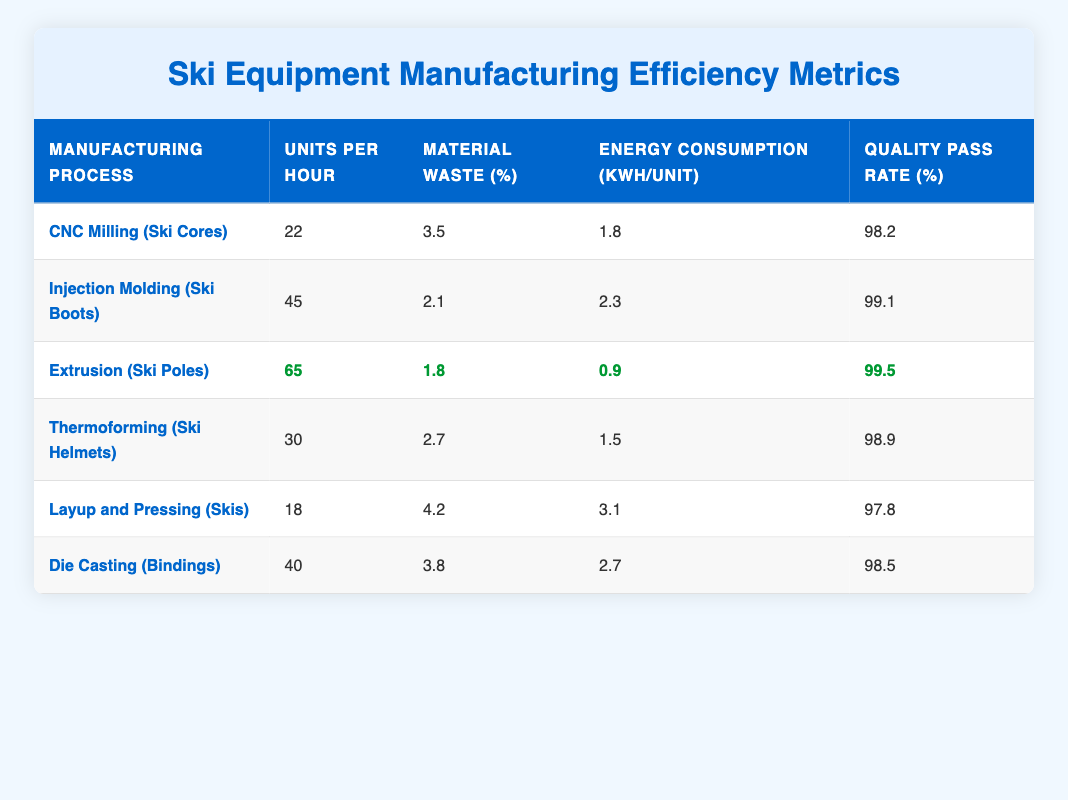What manufacturing process has the highest units produced per hour? By reviewing the "Units per Hour" column, I can see that the "Extrusion (Ski Poles)" process has the highest value at 65 units per hour, compared to others.
Answer: Extrusion (Ski Poles) Which manufacturing process has the lowest material waste percentage? Looking at the "Material Waste (%)" column, I can find that the "Extrusion (Ski Poles)" process has the lowest waste percentage at 1.8%.
Answer: Extrusion (Ski Poles) Is the quality pass rate for Injection Molding (Ski Boots) greater than 98%? Checking the "Quality Pass Rate (%)" for Injection Molding (Ski Boots), I see that it is 99.1%, which is indeed greater than 98%.
Answer: Yes What is the average energy consumption for all manufacturing processes listed? To find the average energy consumption, I sum all the values: (1.8 + 2.3 + 0.9 + 1.5 + 3.1 + 2.7) = 12.3 kWh. Then I divide by the number of processes, which is 6: 12.3 / 6 = 2.05 kWh per unit.
Answer: 2.05 kWh Which manufacturing process has both a quality pass rate greater than 98% and the lowest energy consumption? I examine the "Quality Pass Rate (%)" and "Energy Consumption (kWh/unit)" columns. The two processes with a quality pass rate greater than 98% are "Injection Molding (Ski Boots)" at 99.1% and "Extrusion (Ski Poles)" at 99.5%. Among those, "Extrusion (Ski Poles)" has the lowest energy consumption of 0.9 kWh/unit.
Answer: Extrusion (Ski Poles) 